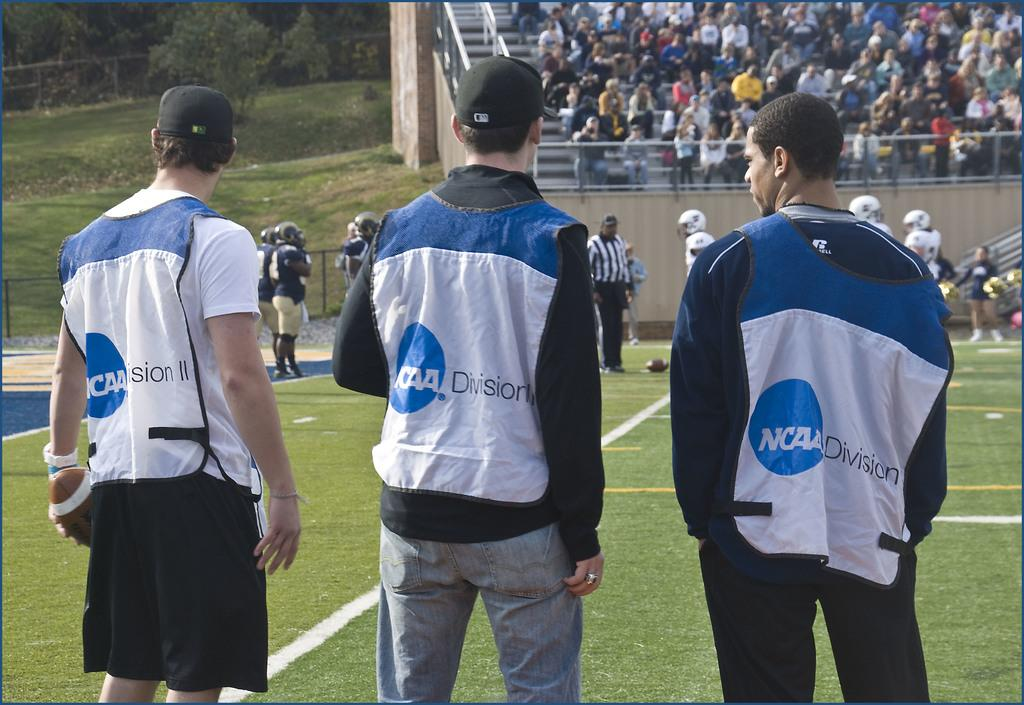<image>
Create a compact narrative representing the image presented. Men wearing jackets that says NCAA Division on it. 